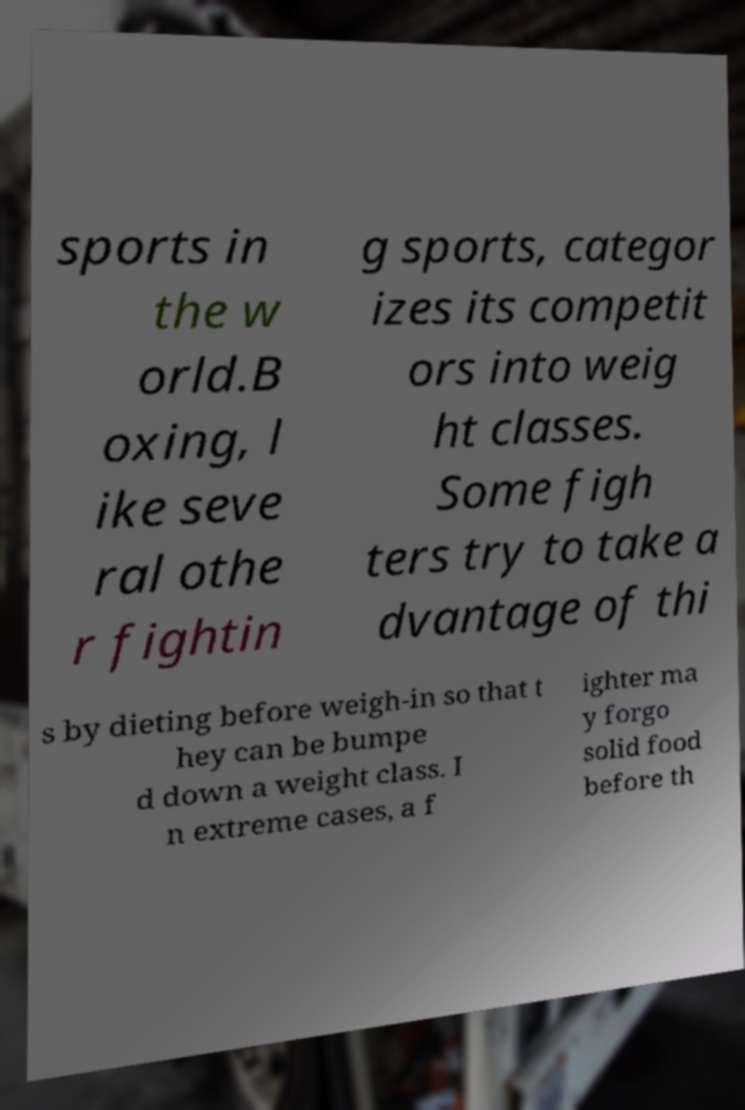Could you extract and type out the text from this image? sports in the w orld.B oxing, l ike seve ral othe r fightin g sports, categor izes its competit ors into weig ht classes. Some figh ters try to take a dvantage of thi s by dieting before weigh-in so that t hey can be bumpe d down a weight class. I n extreme cases, a f ighter ma y forgo solid food before th 